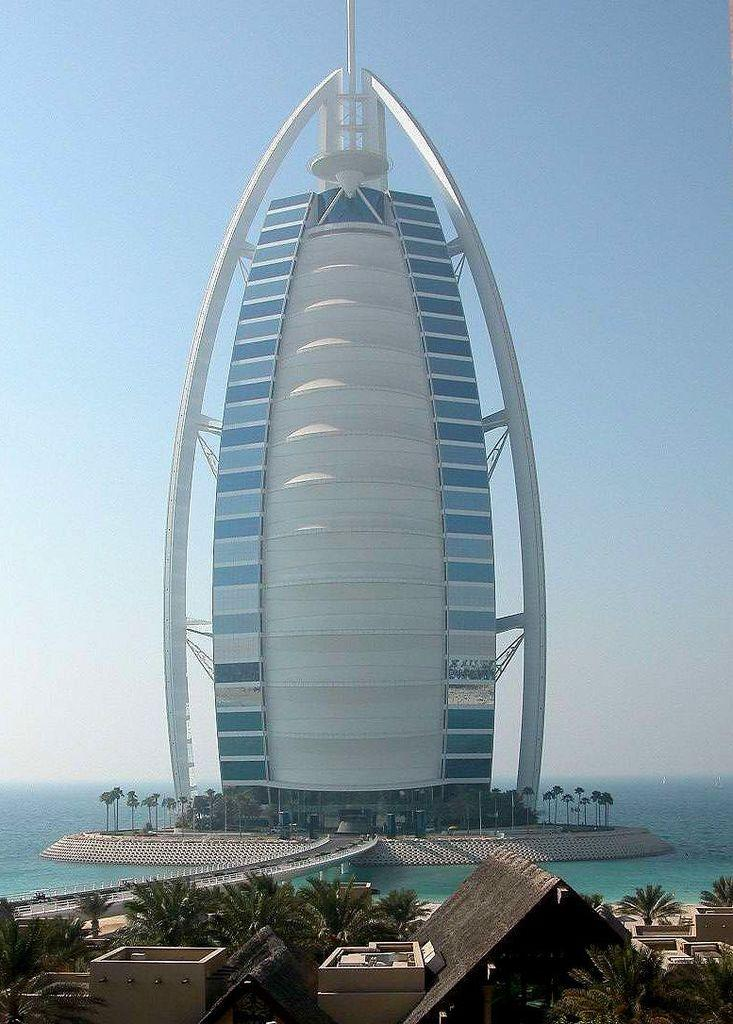What famous building is in the image? The Burj Al Arab building is in the image. Where is the Burj Al Arab building located in the image? The Burj Al Arab building is on the water. What other structures can be seen at the bottom of the image? There are buildings at the bottom of the image. What type of vegetation is present at the bottom of the image? There are trees at the bottom of the image. What can be seen in the background of the image? The sky is visible in the background of the image. How many chairs are placed around the duck in the image? There are no chairs or ducks present in the image; it features the Burj Al Arab building on the water with surrounding buildings and trees. What color is the sock on the Burj Al Arab building in the image? There is no sock present on the Burj Al Arab building or anywhere else in the image. 